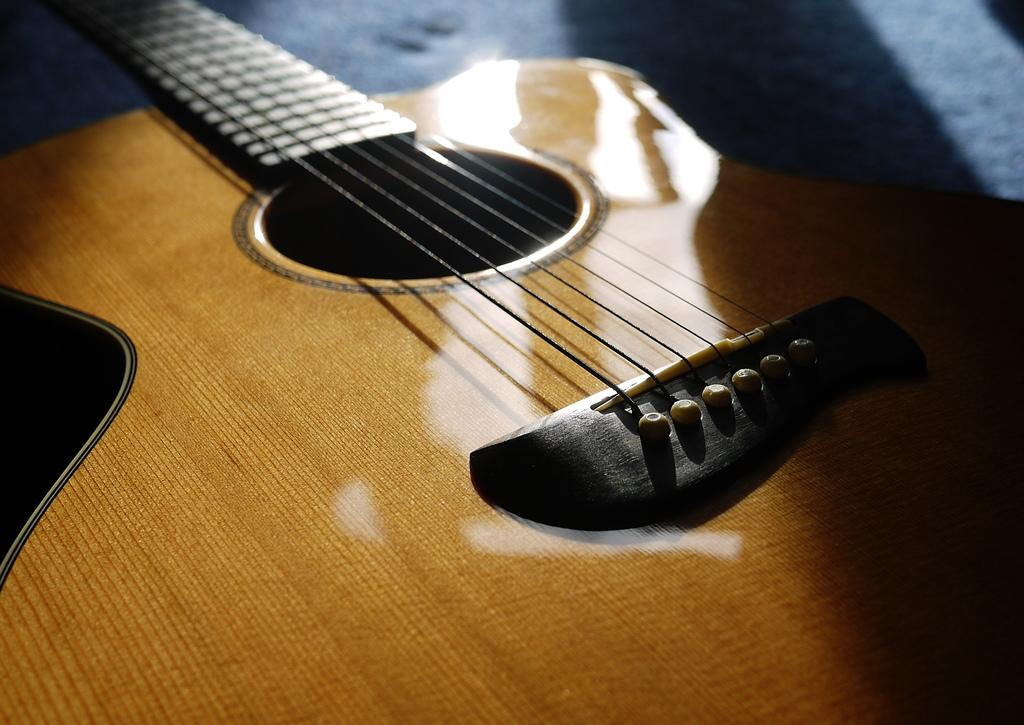What musical instrument is present in the image? There is a guitar in the image. How many strings does the guitar have? The guitar has six strings. What type of appliance is being used by the dad in the cellar in the image? There is no appliance, dad, or cellar present in the image; it only features a guitar with six strings. 